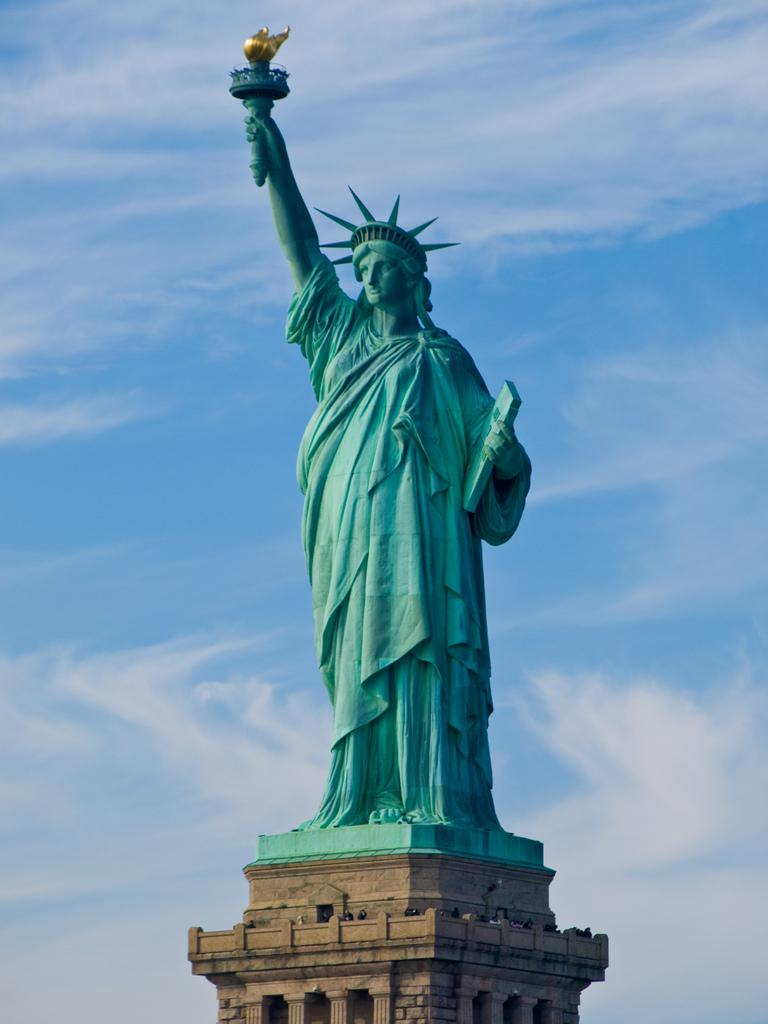What is the main subject in the center of the image? There is a statue in the center of the image. What type of structure is at the bottom of the image? There is a wall-like structure at the bottom of the image. What can be seen in the background of the image? The sky is visible in the background of the image. Can you tell me what question the goat is asking in the image? There is no goat present in the image, so it is not possible to answer that question. 